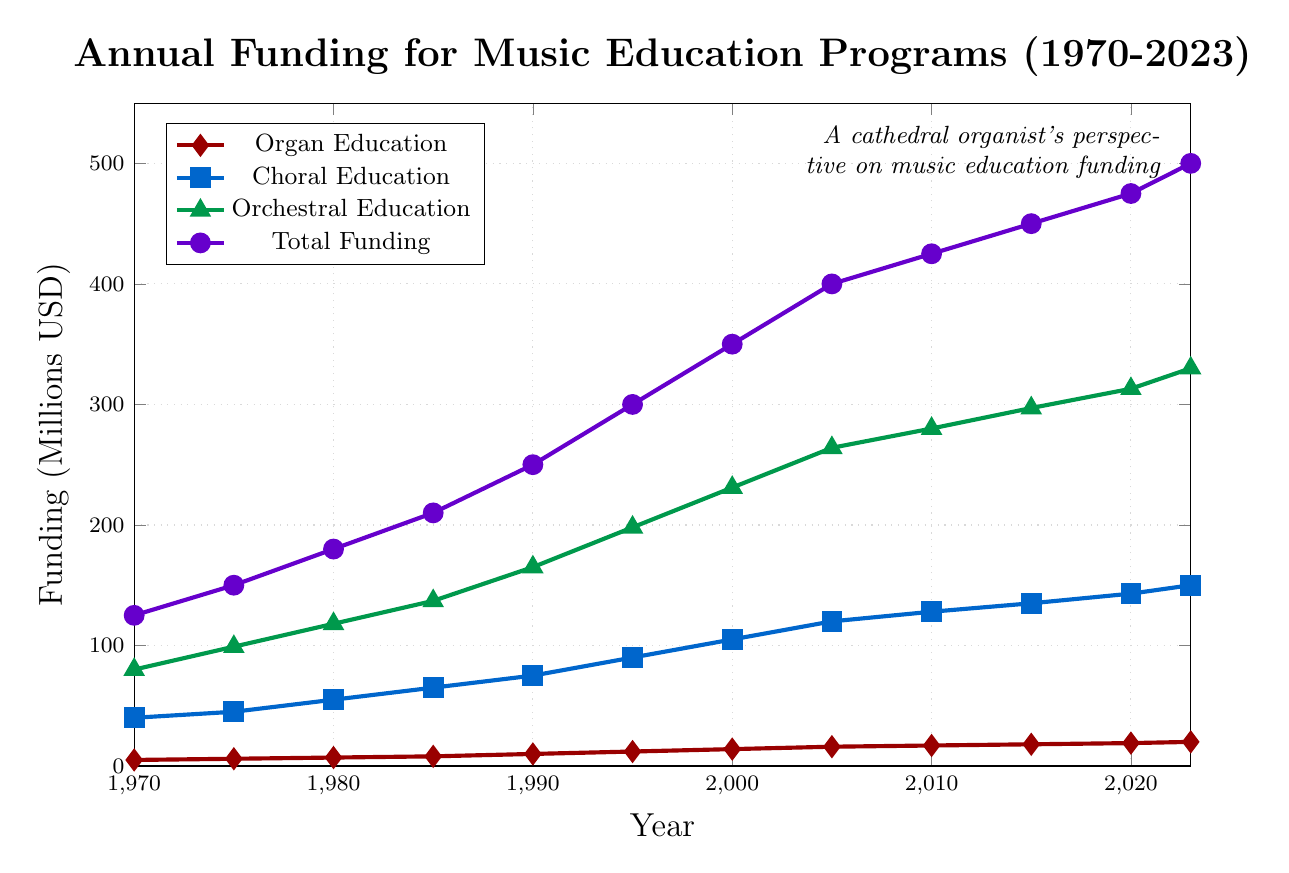Which year received the highest total funding for music education programs? From the figure, the highest total funding amount can be seen at the end of the timeline in 2023 where the total funding is marked at $500 million.
Answer: 2023 What is the difference in funding between Choral Education in 1980 and 2020? To find the difference, we need to refer to the funding amounts for Choral Education in 1980 and 2020. In 1980, Choral Education funding was $55 million, and in 2020, it was $143 million. The difference is $143 million - $55 million.
Answer: $88 million How did Organ Education funding trend from 1970 to 2023? The line representing Organ Education funding shows a steady increase over the years from $5 million in 1970 to $20 million in 2023. This means it has consistently risen.
Answer: Steadily increased Which type of music education received the most funding in 1990? By comparing the marks at 1990 for each type of funding, we can see that Orchestral Education received the highest funding at $165 million, which is greater than the other categories.
Answer: Orchestral Education What is the average funding for Orchestral Education from 1970 to 2020? To find the average, sum the funding amounts for Orchestral Education from 1970 to 2020 and then divide by the number of years. Sum = 80 + 99 + 118 + 137 + 165 + 198 + 231 + 264 + 280 + 297 + 313. Average = Sum / 11.
Answer: $207.18 million Which type of education saw the least funding growth from 1980 to 2005? Comparing the difference in funding for each category from 1980 to 2005, Organ Education increased from 7 to 16 (9 million increase), Choral Education from 55 to 120 (65 million increase), and Orchestral Education from 118 to 264 (146 million increase). Organ Education shows the least growth.
Answer: Organ Education By how many millions did the total funding increase from 1970 to 2023? The total funding in 1970 was $125 million, and in 2023 it was $500 million. The difference is $500 million - $125 million.
Answer: $375 million What was the trend in total funding from 2005 to 2010 and how is it visually represented? Visually, the line representing total funding shows a smooth, gradual increase from $400 million in 2005 to $425 million in 2010, indicating a steady upward trend.
Answer: Gradual increase Between which consecutive years did Choral Education funding see the largest increase? By examining the Choral Education line, the largest increase occurred between 1995 ($90 million) and 2000 ($105 million), a difference of $15 million.
Answer: 1995 to 2000 